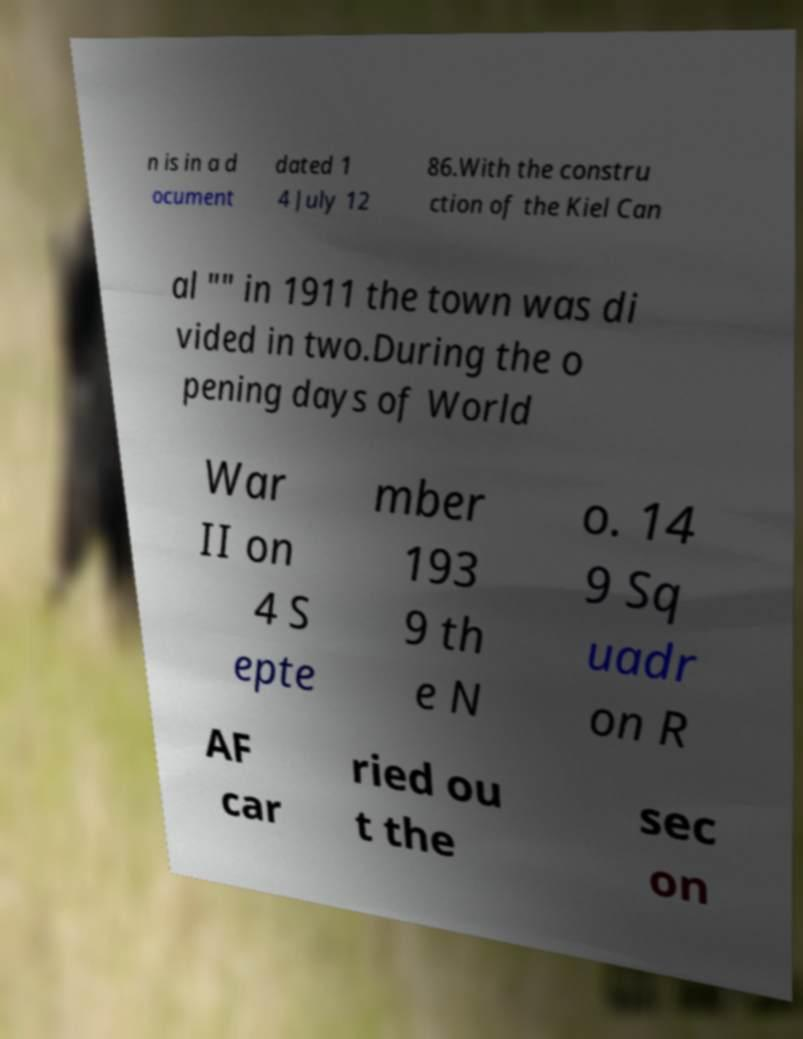There's text embedded in this image that I need extracted. Can you transcribe it verbatim? n is in a d ocument dated 1 4 July 12 86.With the constru ction of the Kiel Can al "" in 1911 the town was di vided in two.During the o pening days of World War II on 4 S epte mber 193 9 th e N o. 14 9 Sq uadr on R AF car ried ou t the sec on 